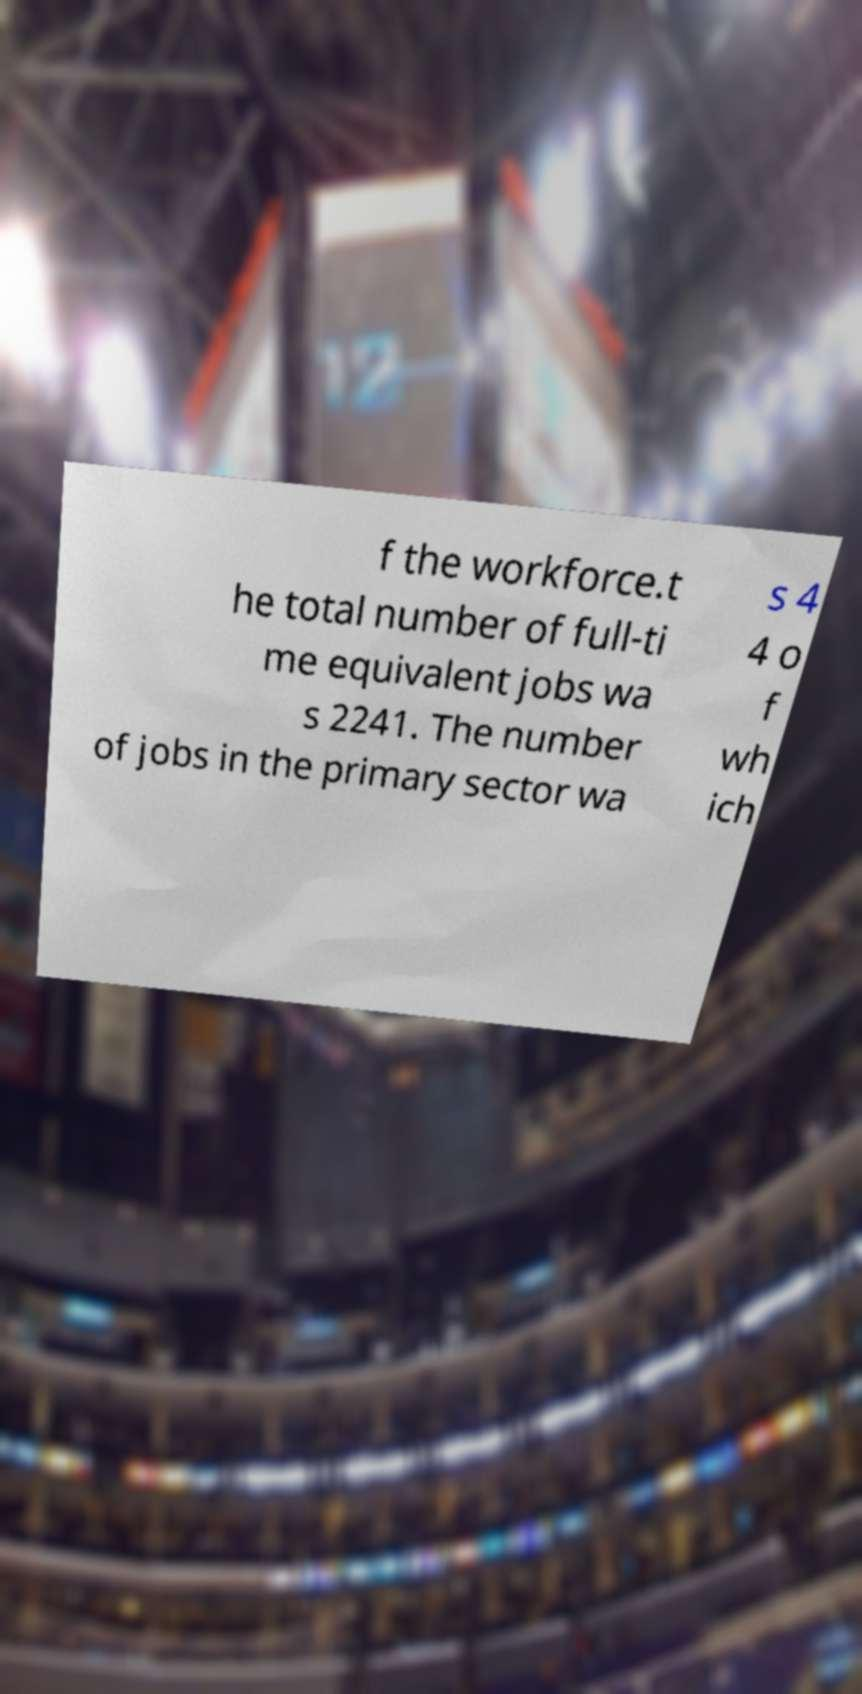Can you accurately transcribe the text from the provided image for me? f the workforce.t he total number of full-ti me equivalent jobs wa s 2241. The number of jobs in the primary sector wa s 4 4 o f wh ich 